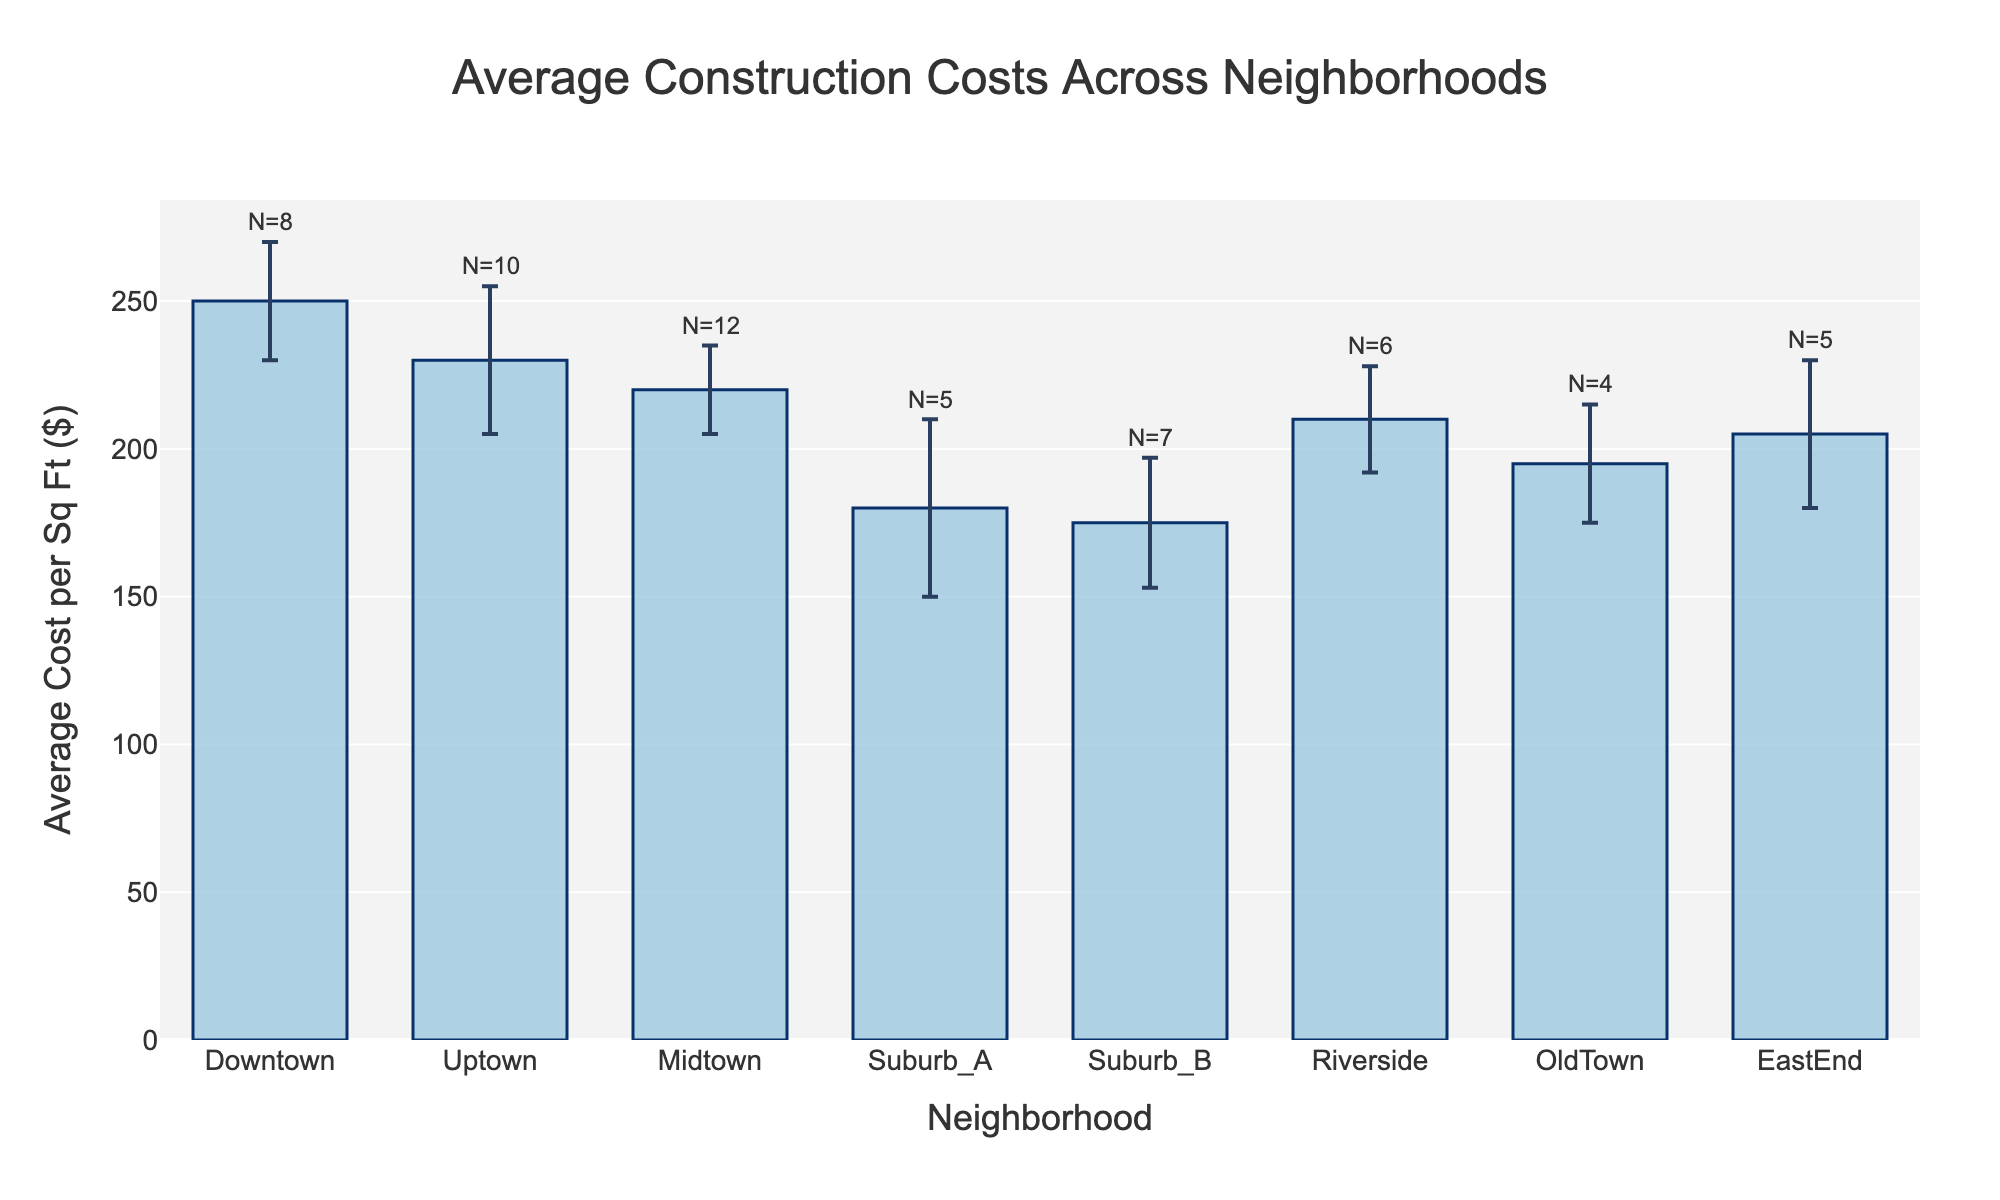What is the highest average construction cost per square foot among the neighborhoods? The bar corresponding to Downtown is the highest, with an average construction cost of $250 per square foot.
Answer: $250 Which neighborhood has the lowest average construction cost per square foot? Suburb_B has the lowest bar in the figure, representing an average construction cost of $175 per square foot.
Answer: $175 How many neighborhoods have a standard deviation greater than 20? The neighborhoods with standard deviations greater than 20 are Uptown, Suburb_A, and EastEnd. Thus, there are three such neighborhoods.
Answer: 3 What is the average cost per square foot for Midtown, and what is its corresponding standard deviation? The bar for Midtown has an average cost of $220 per square foot with error bars representing a standard deviation of $15.
Answer: $220 and $15 Which neighborhoods have an error bar extending above an average construction cost of $250? The error bars for Uptown (230 + 25 = 255) and Suburb_A (180 + 30 = 210) exceed $250 but only Uptown extends above $250.
Answer: Uptown What is the total number of construction projects across all neighborhoods? Sum the number of projects: 8 + 10 + 12 + 5 + 7 + 6 + 4 + 5 = 57.
Answer: 57 If you combine the average construction costs of Downtown and Riverside, what is their total average cost per square foot? Add Downtown's average cost ($250) and Riverside's average cost ($210): $250 + $210 = $460.
Answer: $460 Which neighborhood has the third highest average construction cost per square foot? By inspecting the heights of the bars, the third highest bar corresponds to Midtown, which has an average cost of $220 per square foot.
Answer: Midtown What is the difference in average construction cost per square foot between Downtown and Suburb_B? Subtract the average cost of Suburb_B ($175) from Downtown ($250): $250 - $175 = $75.
Answer: $75 How does the variability in construction costs for Suburb_A compare to Downtown? The standard deviation (error bars) for Suburb_A is $30, while it is $20 for Downtown, indicating that Suburb_A has greater variability.
Answer: Greater in Suburb_A 